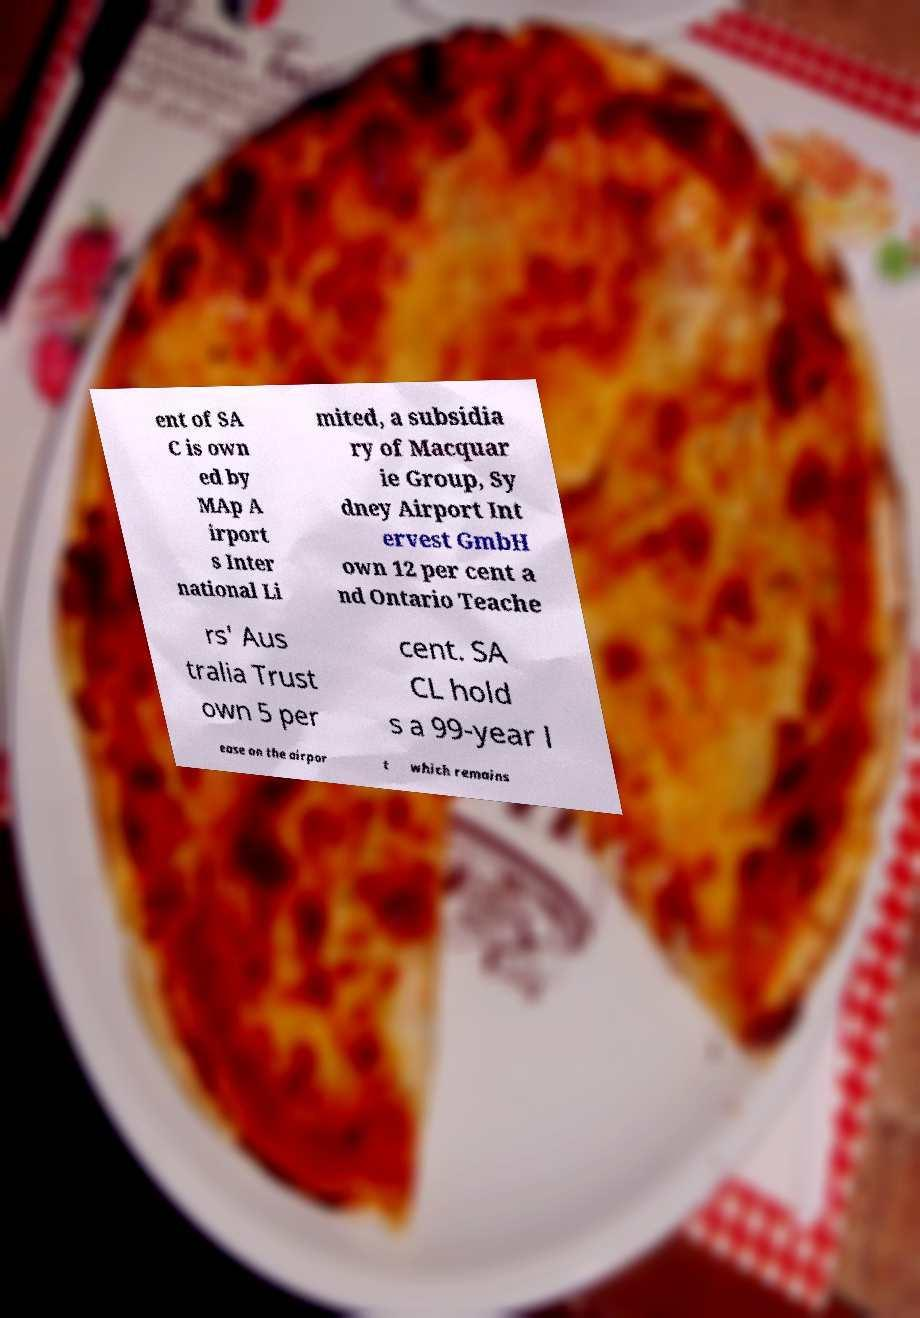I need the written content from this picture converted into text. Can you do that? ent of SA C is own ed by MAp A irport s Inter national Li mited, a subsidia ry of Macquar ie Group, Sy dney Airport Int ervest GmbH own 12 per cent a nd Ontario Teache rs' Aus tralia Trust own 5 per cent. SA CL hold s a 99-year l ease on the airpor t which remains 